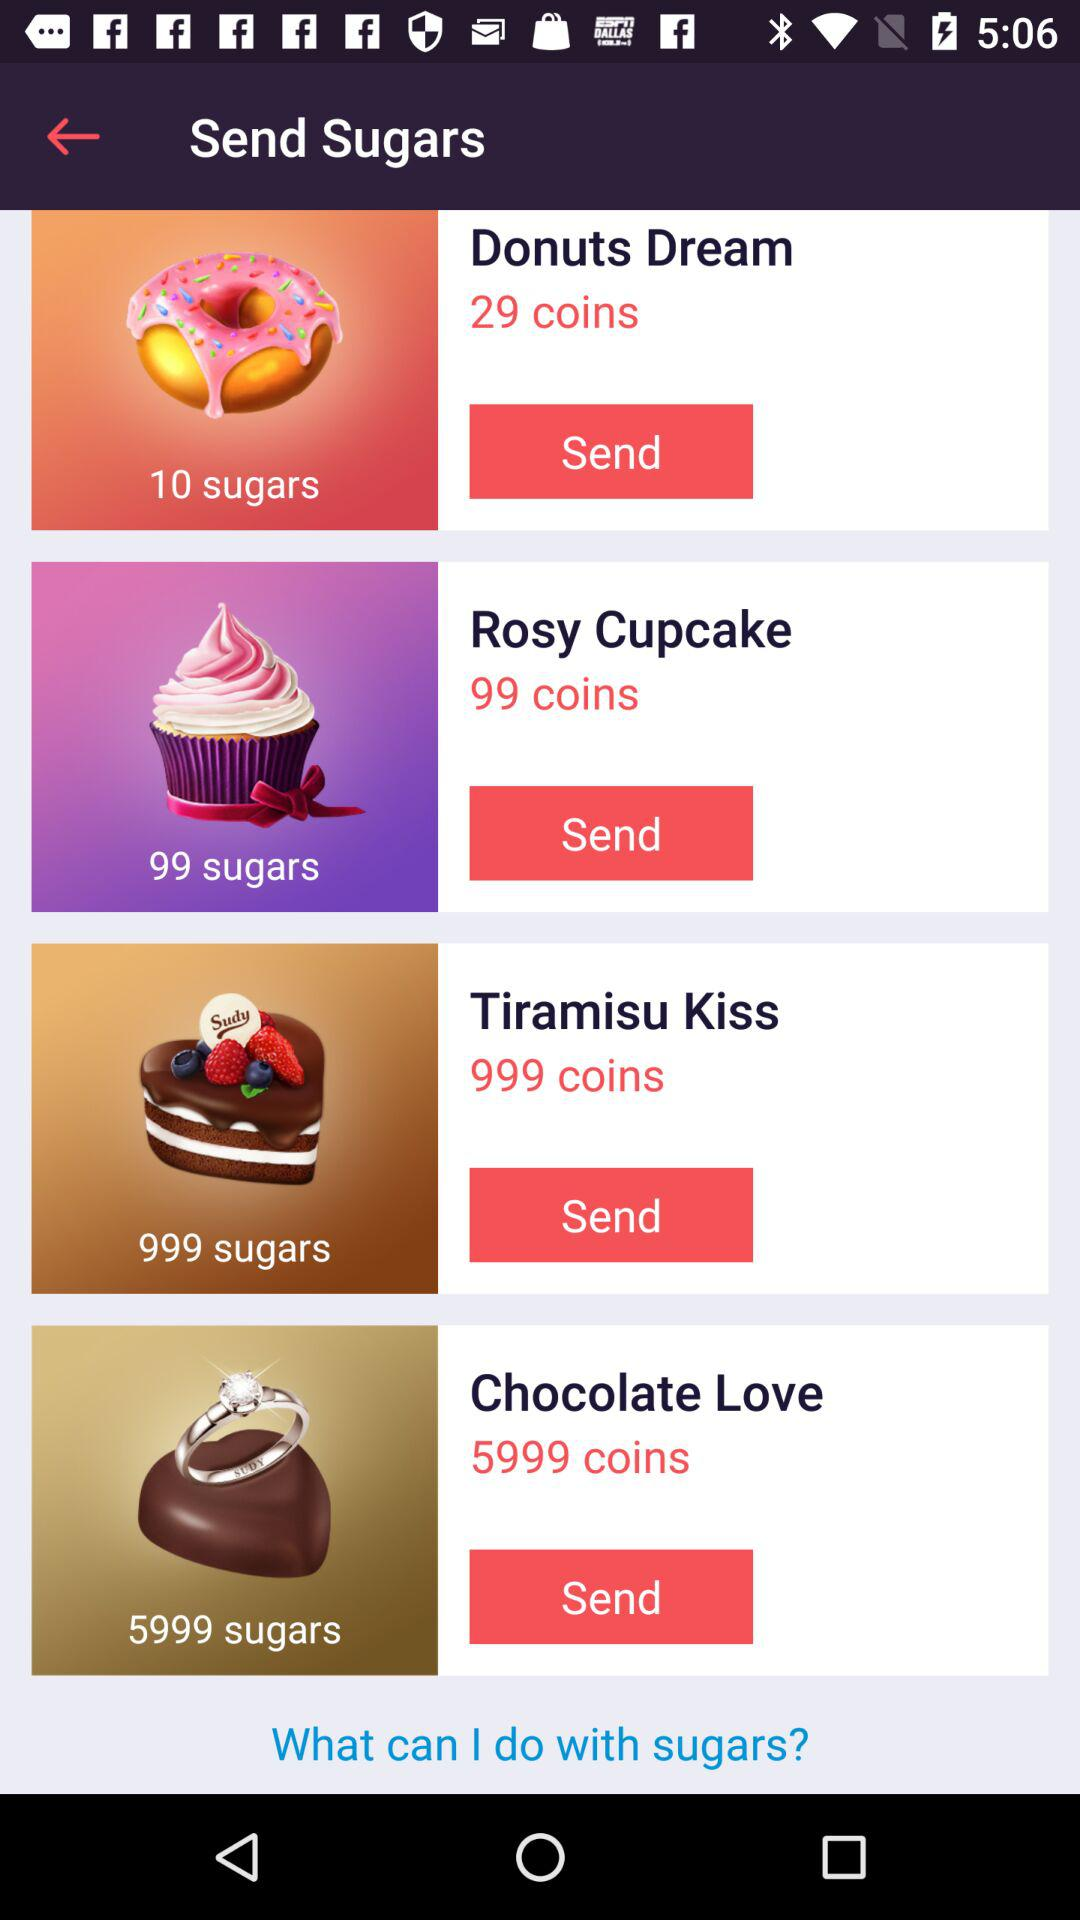How many more sugars does the Chocolate Love cake have than the Tiramisu Kiss cake?
Answer the question using a single word or phrase. 5000 